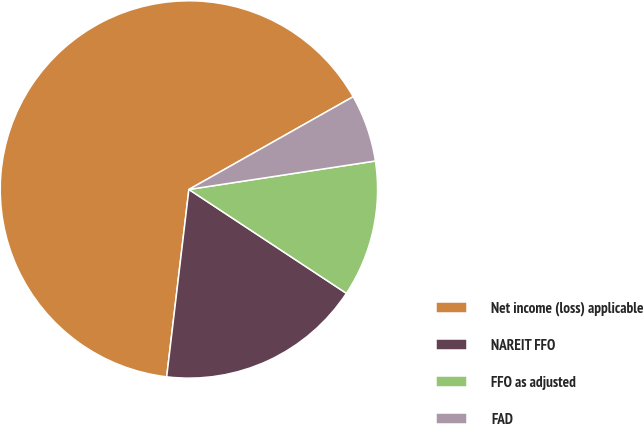<chart> <loc_0><loc_0><loc_500><loc_500><pie_chart><fcel>Net income (loss) applicable<fcel>NAREIT FFO<fcel>FFO as adjusted<fcel>FAD<nl><fcel>64.94%<fcel>17.6%<fcel>11.69%<fcel>5.77%<nl></chart> 